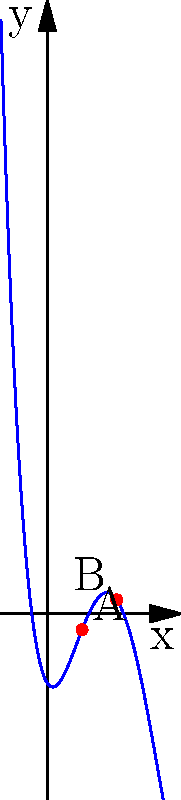Consider the polynomial function depicted in the graph above, which represents the evolution of philosophical thought over time. The x-axis represents historical progression, and the y-axis represents the dominance of certain philosophical paradigms. Points A and B mark significant turning points in this evolution. How might these turning points relate to Thomas Kuhn's concept of paradigm shifts in the philosophy of science, and what implications does this have for our understanding of philosophical progress? To answer this question, let's break it down step-by-step:

1. Understand the graph:
   - The graph represents a polynomial function with two turning points (A and B).
   - In the context of philosophical thought, these turning points represent significant shifts or changes in dominant paradigms.

2. Relate to Kuhn's concept of paradigm shifts:
   - Thomas Kuhn introduced the idea of paradigm shifts in his book "The Structure of Scientific Revolutions."
   - Kuhn argued that scientific progress isn't linear but occurs through revolutionary changes in worldviews or paradigms.

3. Interpret turning points A and B:
   - Point A: This could represent a major shift from one philosophical paradigm to another. For example, the shift from ancient to medieval philosophy, or from medieval to modern philosophy.
   - Point B: This might represent another significant shift, such as the emergence of postmodern philosophy or the analytic-continental divide.

4. Analyze the shape of the function between and around these points:
   - The curve between A and B shows a period of relative stability and gradual change within a paradigm.
   - The steeper slopes before A and after B might represent periods of rapid change or crisis leading to paradigm shifts.

5. Consider implications for understanding philosophical progress:
   - Non-linearity: The curve suggests that philosophical progress isn't linear, mirroring Kuhn's view of scientific progress.
   - Periods of stability and revolution: The graph shows both gradual changes and sudden shifts, implying that philosophical thought evolves through both incremental developments and revolutionary changes.
   - Complexity of progress: The polynomial nature of the function suggests that philosophical progress is complex, with multiple factors influencing its trajectory.

6. Reflect on the limitations of the model:
   - While this graph provides a useful visualization, it's important to note that real philosophical progress is more complex and multidimensional than a single polynomial function can represent.

In conclusion, this graphical representation of philosophical thought evolution aligns well with Kuhn's concept of paradigm shifts, suggesting that philosophical progress, like scientific progress, occurs through periods of relative stability punctuated by revolutionary changes in thinking.
Answer: The turning points represent paradigm shifts in philosophical thinking, suggesting that philosophical progress, like scientific progress in Kuhn's theory, occurs through periods of stability interrupted by revolutionary changes, implying a non-linear and complex evolution of thought. 